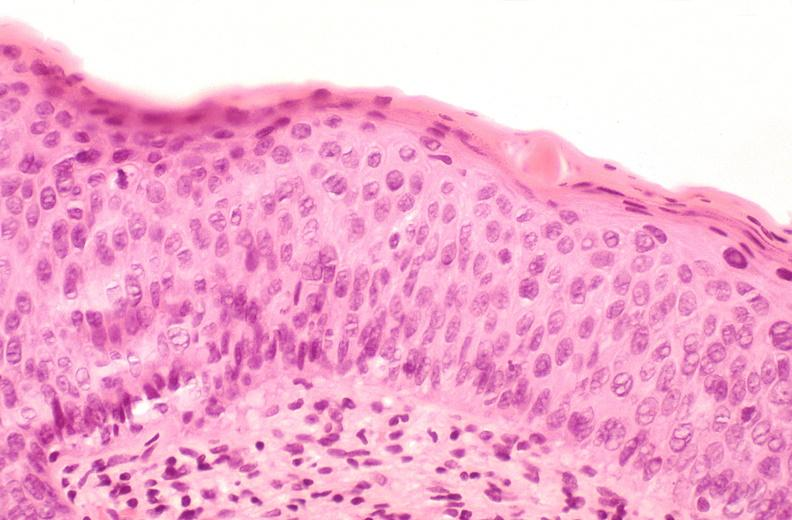what does this image show?
Answer the question using a single word or phrase. Cervix 